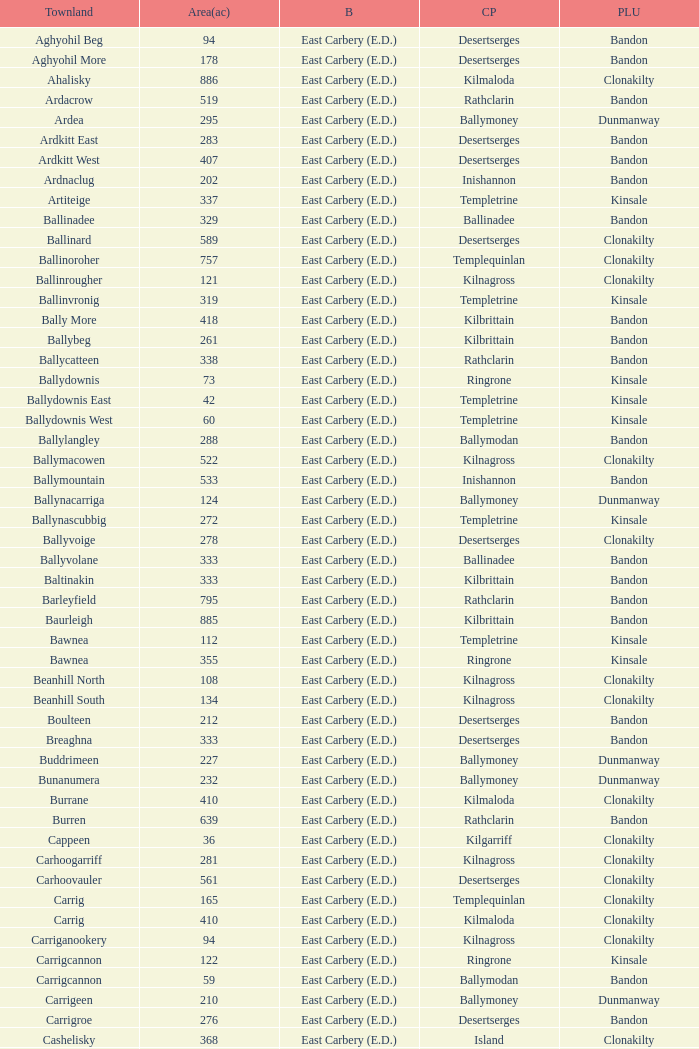What is the poor law union of the Lackenagobidane townland? Clonakilty. 